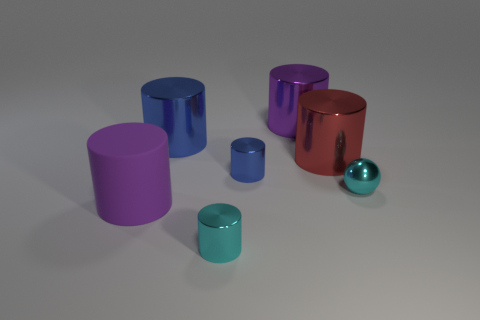What shape is the blue shiny thing that is the same size as the red object?
Provide a succinct answer. Cylinder. Are there any other things that are the same color as the big rubber cylinder?
Offer a terse response. Yes. There is a purple object that is the same material as the red object; what size is it?
Your answer should be very brief. Large. Does the big purple metallic object have the same shape as the cyan object in front of the metal sphere?
Your response must be concise. Yes. How big is the sphere?
Keep it short and to the point. Small. Is the number of red shiny cylinders left of the small cyan shiny sphere less than the number of tiny shiny objects?
Your answer should be compact. Yes. What number of blue things have the same size as the purple metal thing?
Your response must be concise. 1. There is a small object that is the same color as the metallic sphere; what is its shape?
Offer a terse response. Cylinder. There is a cylinder that is behind the large blue metallic cylinder; is its color the same as the tiny object that is to the right of the red object?
Your response must be concise. No. There is a big purple metallic cylinder; what number of shiny spheres are to the left of it?
Give a very brief answer. 0. 